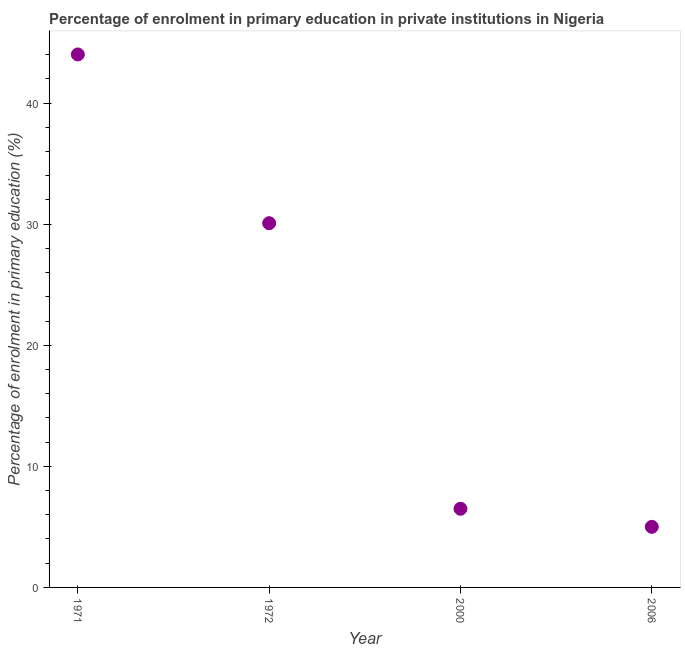What is the enrolment percentage in primary education in 1971?
Provide a short and direct response. 44.02. Across all years, what is the maximum enrolment percentage in primary education?
Keep it short and to the point. 44.02. Across all years, what is the minimum enrolment percentage in primary education?
Give a very brief answer. 5. In which year was the enrolment percentage in primary education minimum?
Your answer should be compact. 2006. What is the sum of the enrolment percentage in primary education?
Give a very brief answer. 85.61. What is the difference between the enrolment percentage in primary education in 1972 and 2006?
Provide a short and direct response. 25.08. What is the average enrolment percentage in primary education per year?
Provide a succinct answer. 21.4. What is the median enrolment percentage in primary education?
Your response must be concise. 18.29. What is the ratio of the enrolment percentage in primary education in 1972 to that in 2006?
Your response must be concise. 6.01. Is the enrolment percentage in primary education in 1971 less than that in 2000?
Give a very brief answer. No. Is the difference between the enrolment percentage in primary education in 1971 and 2006 greater than the difference between any two years?
Offer a very short reply. Yes. What is the difference between the highest and the second highest enrolment percentage in primary education?
Keep it short and to the point. 13.94. Is the sum of the enrolment percentage in primary education in 1971 and 1972 greater than the maximum enrolment percentage in primary education across all years?
Your answer should be compact. Yes. What is the difference between the highest and the lowest enrolment percentage in primary education?
Give a very brief answer. 39.02. In how many years, is the enrolment percentage in primary education greater than the average enrolment percentage in primary education taken over all years?
Make the answer very short. 2. Does the enrolment percentage in primary education monotonically increase over the years?
Your answer should be compact. No. How many dotlines are there?
Provide a short and direct response. 1. How many years are there in the graph?
Provide a succinct answer. 4. Does the graph contain any zero values?
Your answer should be very brief. No. What is the title of the graph?
Keep it short and to the point. Percentage of enrolment in primary education in private institutions in Nigeria. What is the label or title of the Y-axis?
Your answer should be compact. Percentage of enrolment in primary education (%). What is the Percentage of enrolment in primary education (%) in 1971?
Provide a short and direct response. 44.02. What is the Percentage of enrolment in primary education (%) in 1972?
Offer a terse response. 30.08. What is the Percentage of enrolment in primary education (%) in 2000?
Offer a very short reply. 6.5. What is the Percentage of enrolment in primary education (%) in 2006?
Ensure brevity in your answer.  5. What is the difference between the Percentage of enrolment in primary education (%) in 1971 and 1972?
Your answer should be compact. 13.94. What is the difference between the Percentage of enrolment in primary education (%) in 1971 and 2000?
Provide a succinct answer. 37.52. What is the difference between the Percentage of enrolment in primary education (%) in 1971 and 2006?
Provide a short and direct response. 39.02. What is the difference between the Percentage of enrolment in primary education (%) in 1972 and 2000?
Your answer should be compact. 23.59. What is the difference between the Percentage of enrolment in primary education (%) in 1972 and 2006?
Your answer should be very brief. 25.08. What is the difference between the Percentage of enrolment in primary education (%) in 2000 and 2006?
Keep it short and to the point. 1.49. What is the ratio of the Percentage of enrolment in primary education (%) in 1971 to that in 1972?
Ensure brevity in your answer.  1.46. What is the ratio of the Percentage of enrolment in primary education (%) in 1971 to that in 2000?
Provide a short and direct response. 6.78. What is the ratio of the Percentage of enrolment in primary education (%) in 1971 to that in 2006?
Provide a succinct answer. 8.8. What is the ratio of the Percentage of enrolment in primary education (%) in 1972 to that in 2000?
Your response must be concise. 4.63. What is the ratio of the Percentage of enrolment in primary education (%) in 1972 to that in 2006?
Your answer should be very brief. 6.01. What is the ratio of the Percentage of enrolment in primary education (%) in 2000 to that in 2006?
Your response must be concise. 1.3. 